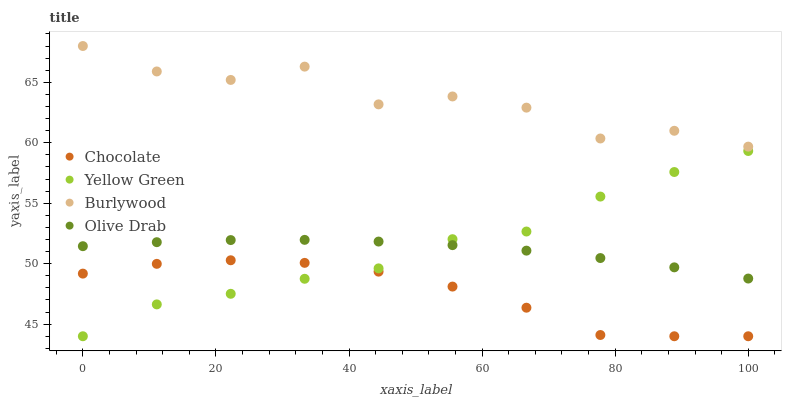Does Chocolate have the minimum area under the curve?
Answer yes or no. Yes. Does Burlywood have the maximum area under the curve?
Answer yes or no. Yes. Does Yellow Green have the minimum area under the curve?
Answer yes or no. No. Does Yellow Green have the maximum area under the curve?
Answer yes or no. No. Is Olive Drab the smoothest?
Answer yes or no. Yes. Is Burlywood the roughest?
Answer yes or no. Yes. Is Yellow Green the smoothest?
Answer yes or no. No. Is Yellow Green the roughest?
Answer yes or no. No. Does Yellow Green have the lowest value?
Answer yes or no. Yes. Does Olive Drab have the lowest value?
Answer yes or no. No. Does Burlywood have the highest value?
Answer yes or no. Yes. Does Yellow Green have the highest value?
Answer yes or no. No. Is Chocolate less than Olive Drab?
Answer yes or no. Yes. Is Burlywood greater than Chocolate?
Answer yes or no. Yes. Does Olive Drab intersect Yellow Green?
Answer yes or no. Yes. Is Olive Drab less than Yellow Green?
Answer yes or no. No. Is Olive Drab greater than Yellow Green?
Answer yes or no. No. Does Chocolate intersect Olive Drab?
Answer yes or no. No. 